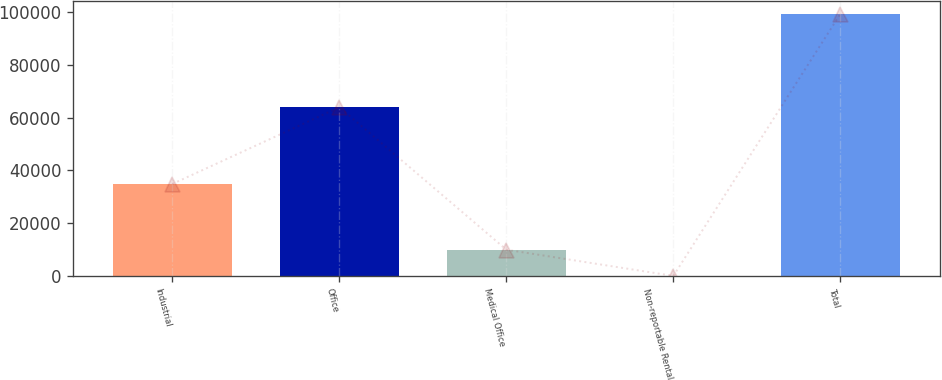Convert chart. <chart><loc_0><loc_0><loc_500><loc_500><bar_chart><fcel>Industrial<fcel>Office<fcel>Medical Office<fcel>Non-reportable Rental<fcel>Total<nl><fcel>34872<fcel>63933<fcel>9970.5<fcel>49<fcel>99264<nl></chart> 